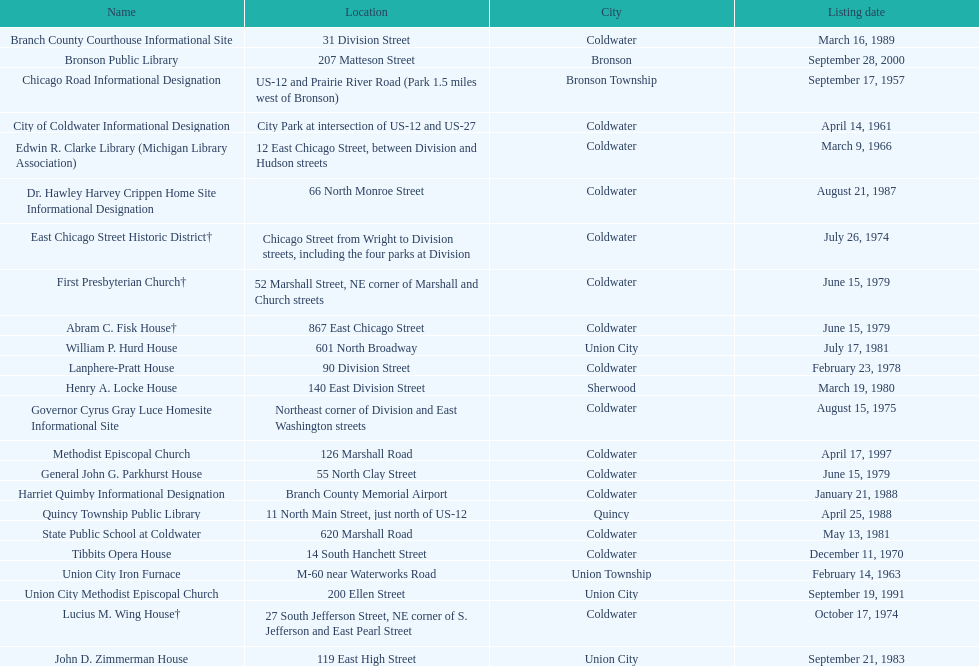How many years passed between the historic listing of public libraries in quincy and bronson? 12. 